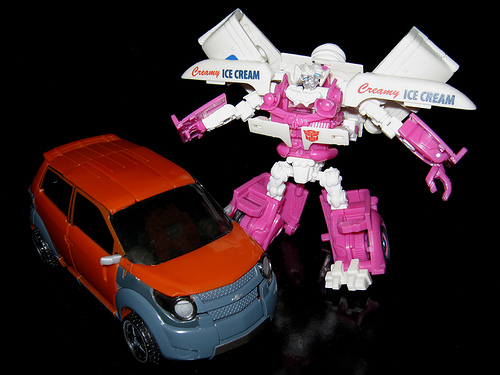<image>
Is there a robot next to the car? Yes. The robot is positioned adjacent to the car, located nearby in the same general area. 